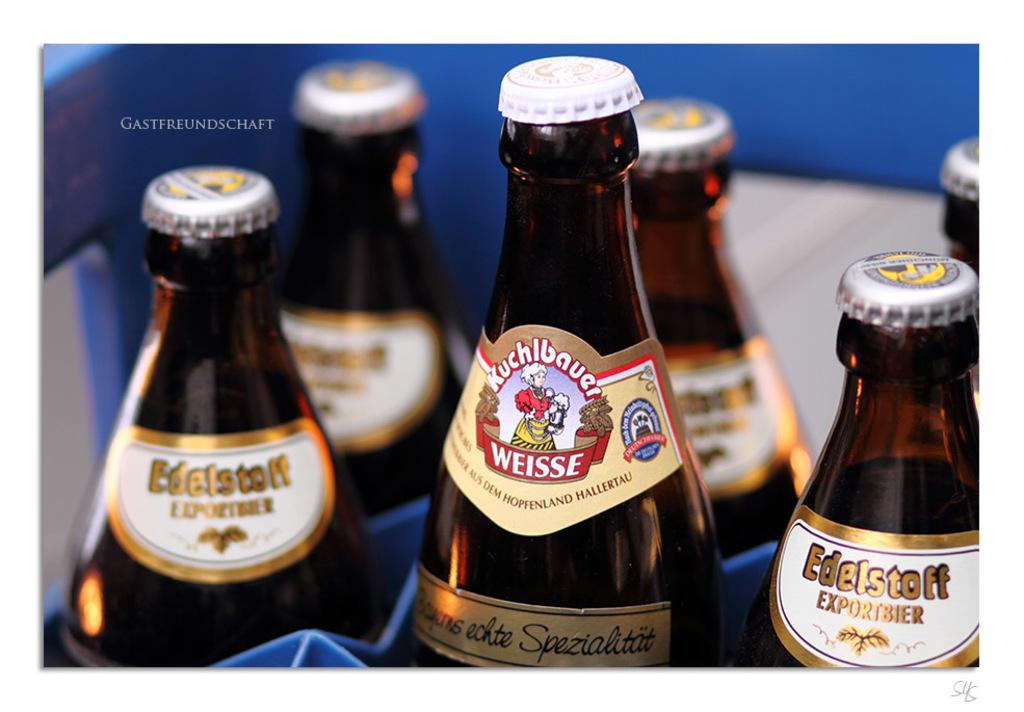<image>
Offer a succinct explanation of the picture presented. A bottle of imported beer has Weisse in white lettering on its colorful label. 